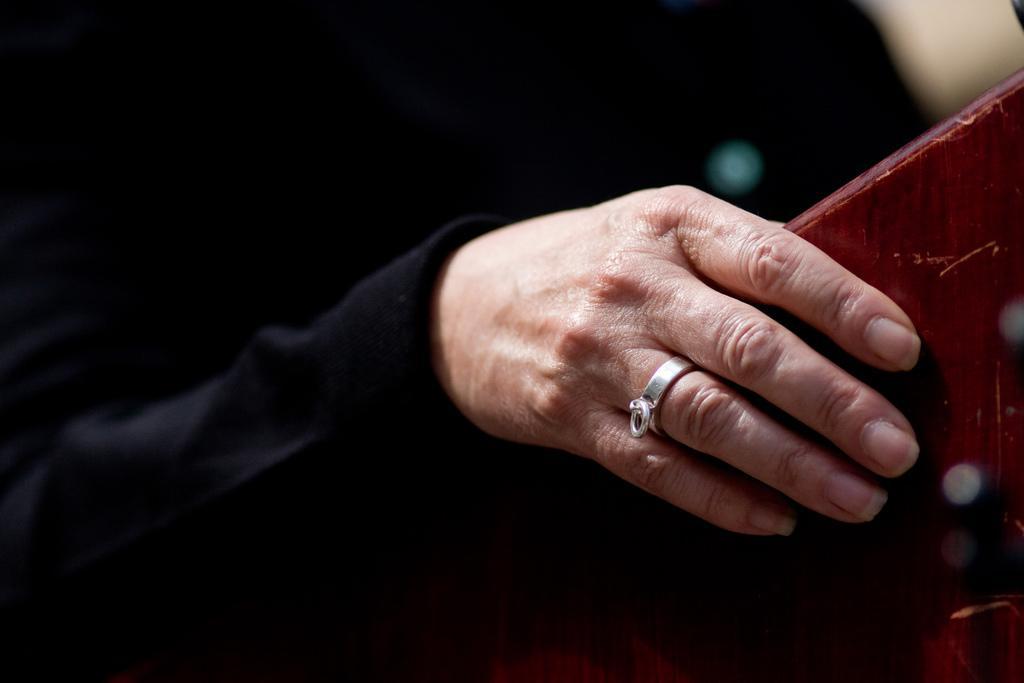How would you summarize this image in a sentence or two? In this image, I can see a person's hand holding an object. The background looks dark. 